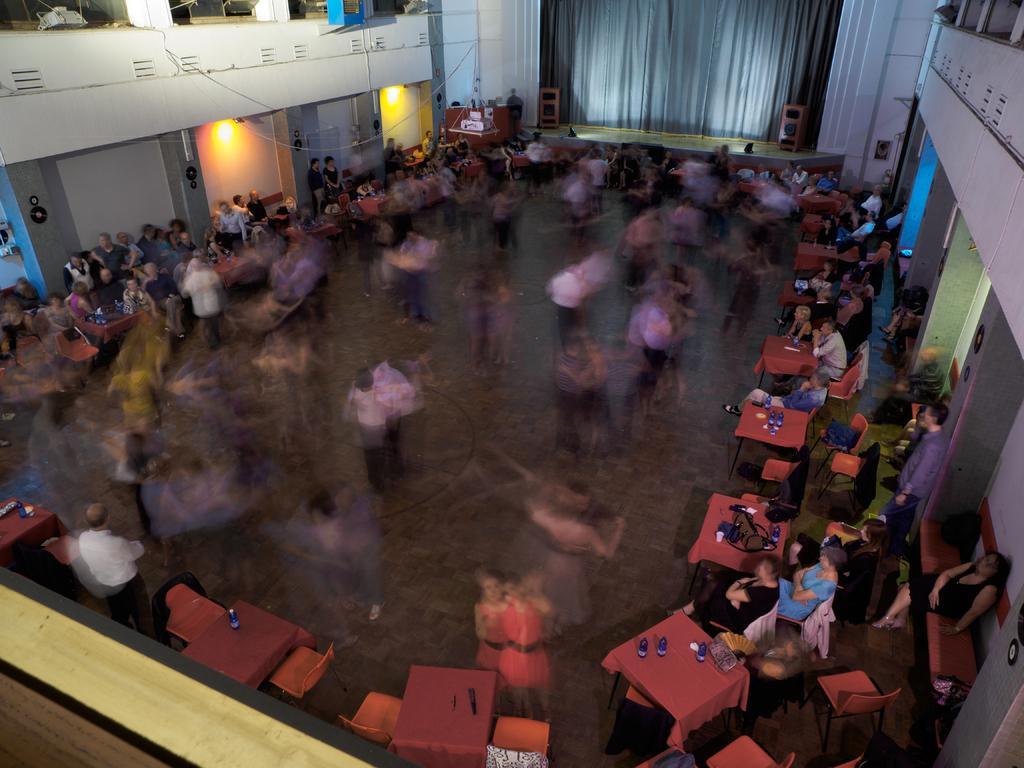Describe this image in one or two sentences. This is a blur image. In the center of the image we can see some people are dancing. In the background of the image we can see the tables, chairs, lights, wall, curtain and some people are sitting on the chairs and some of them are standing. On the tables we can see the objects. In the middle of the image we can see the floor. 